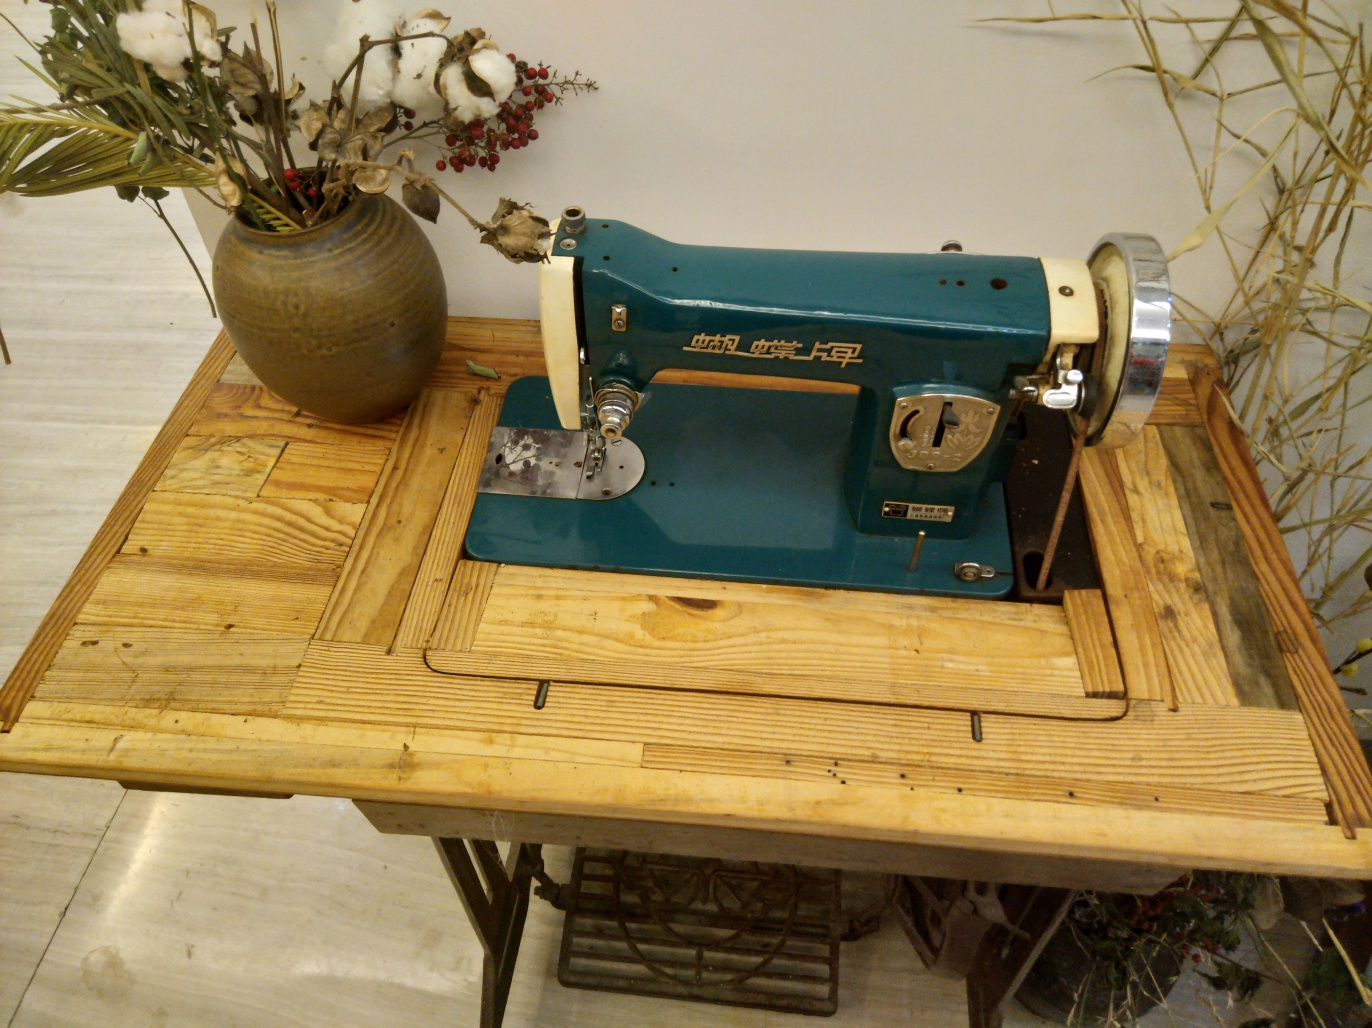Are the details of the cotton and bamboo leaves in the background rich?
A. No
B. Yes
Answer with the option's letter from the given choices directly.
 B. 